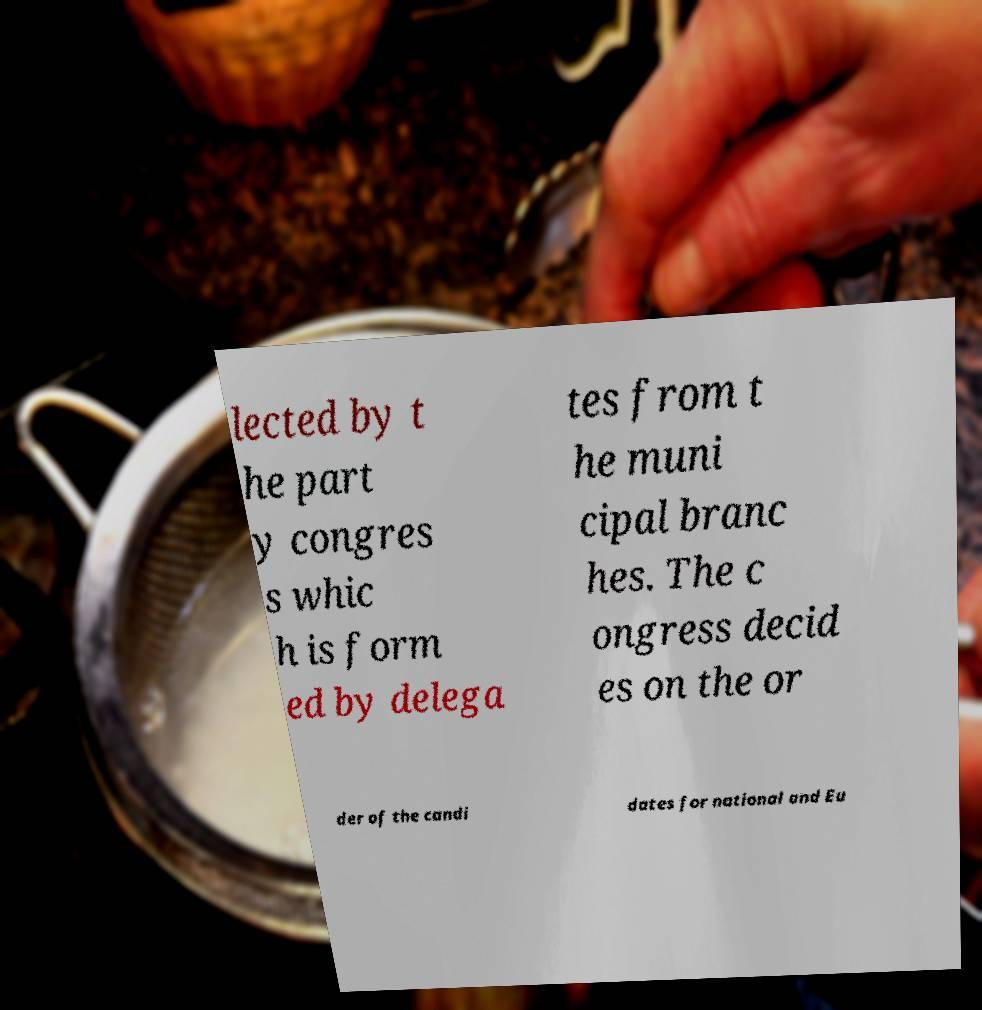Please read and relay the text visible in this image. What does it say? lected by t he part y congres s whic h is form ed by delega tes from t he muni cipal branc hes. The c ongress decid es on the or der of the candi dates for national and Eu 